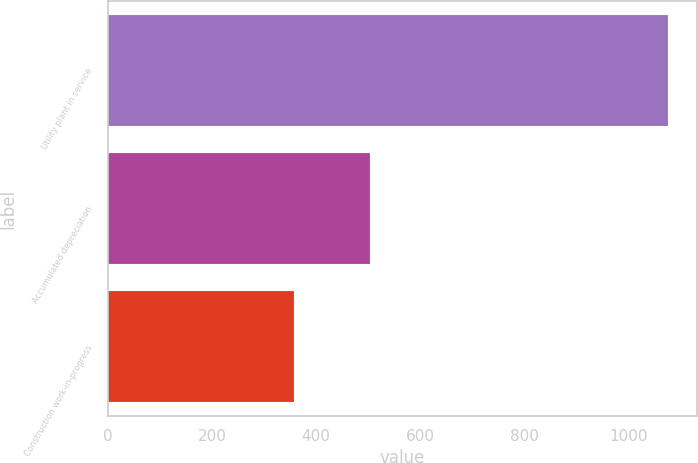Convert chart to OTSL. <chart><loc_0><loc_0><loc_500><loc_500><bar_chart><fcel>Utility plant in service<fcel>Accumulated depreciation<fcel>Construction work-in-progress<nl><fcel>1077<fcel>503<fcel>358<nl></chart> 